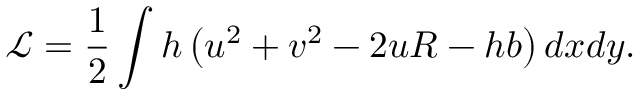Convert formula to latex. <formula><loc_0><loc_0><loc_500><loc_500>\mathcal { L } = \frac { 1 } { 2 } \int h \left ( u ^ { 2 } + v ^ { 2 } - 2 u R - h b \right ) d x d y .</formula> 